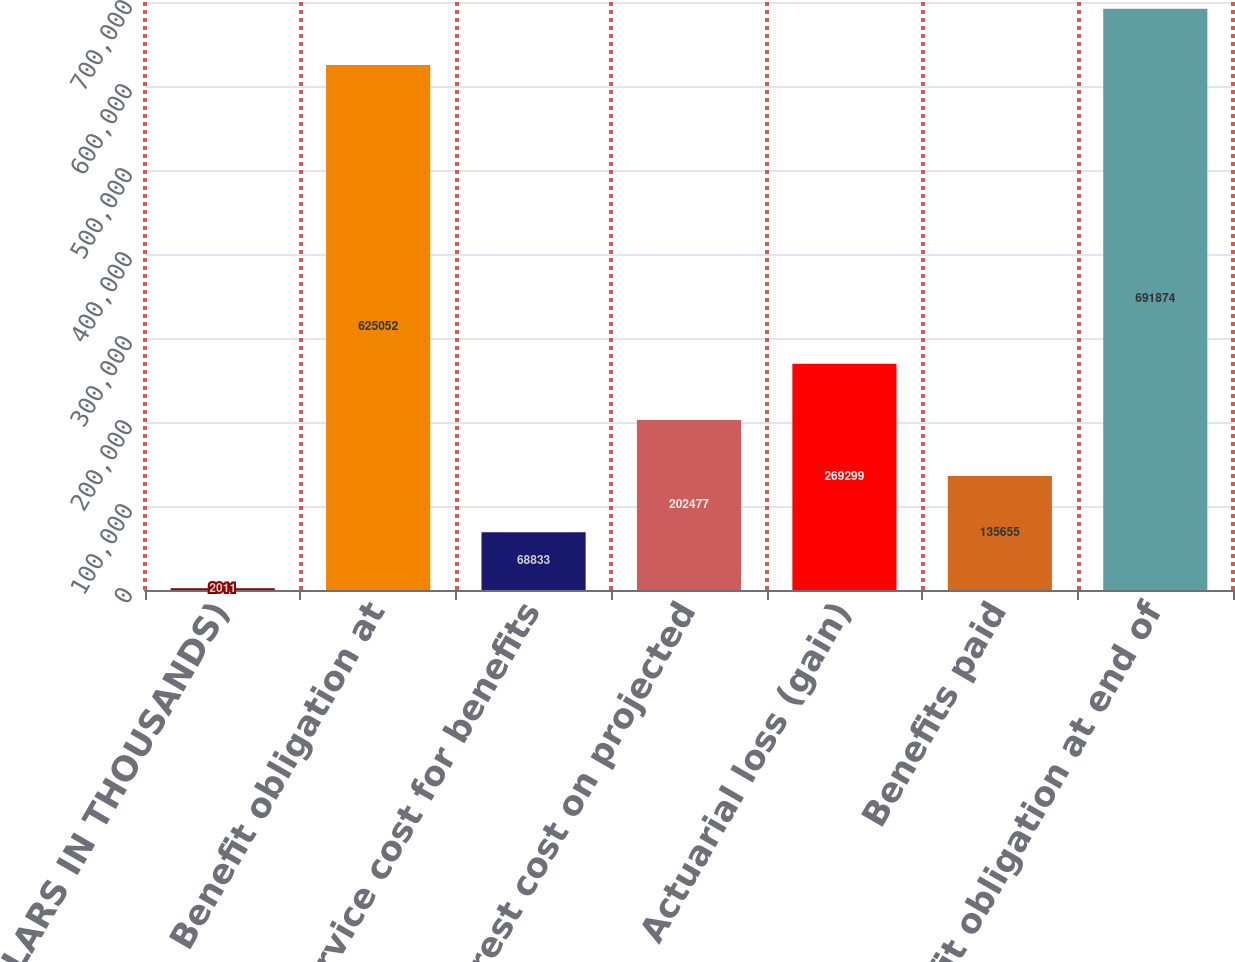Convert chart. <chart><loc_0><loc_0><loc_500><loc_500><bar_chart><fcel>(DOLLARS IN THOUSANDS)<fcel>Benefit obligation at<fcel>Service cost for benefits<fcel>Interest cost on projected<fcel>Actuarial loss (gain)<fcel>Benefits paid<fcel>Benefit obligation at end of<nl><fcel>2011<fcel>625052<fcel>68833<fcel>202477<fcel>269299<fcel>135655<fcel>691874<nl></chart> 